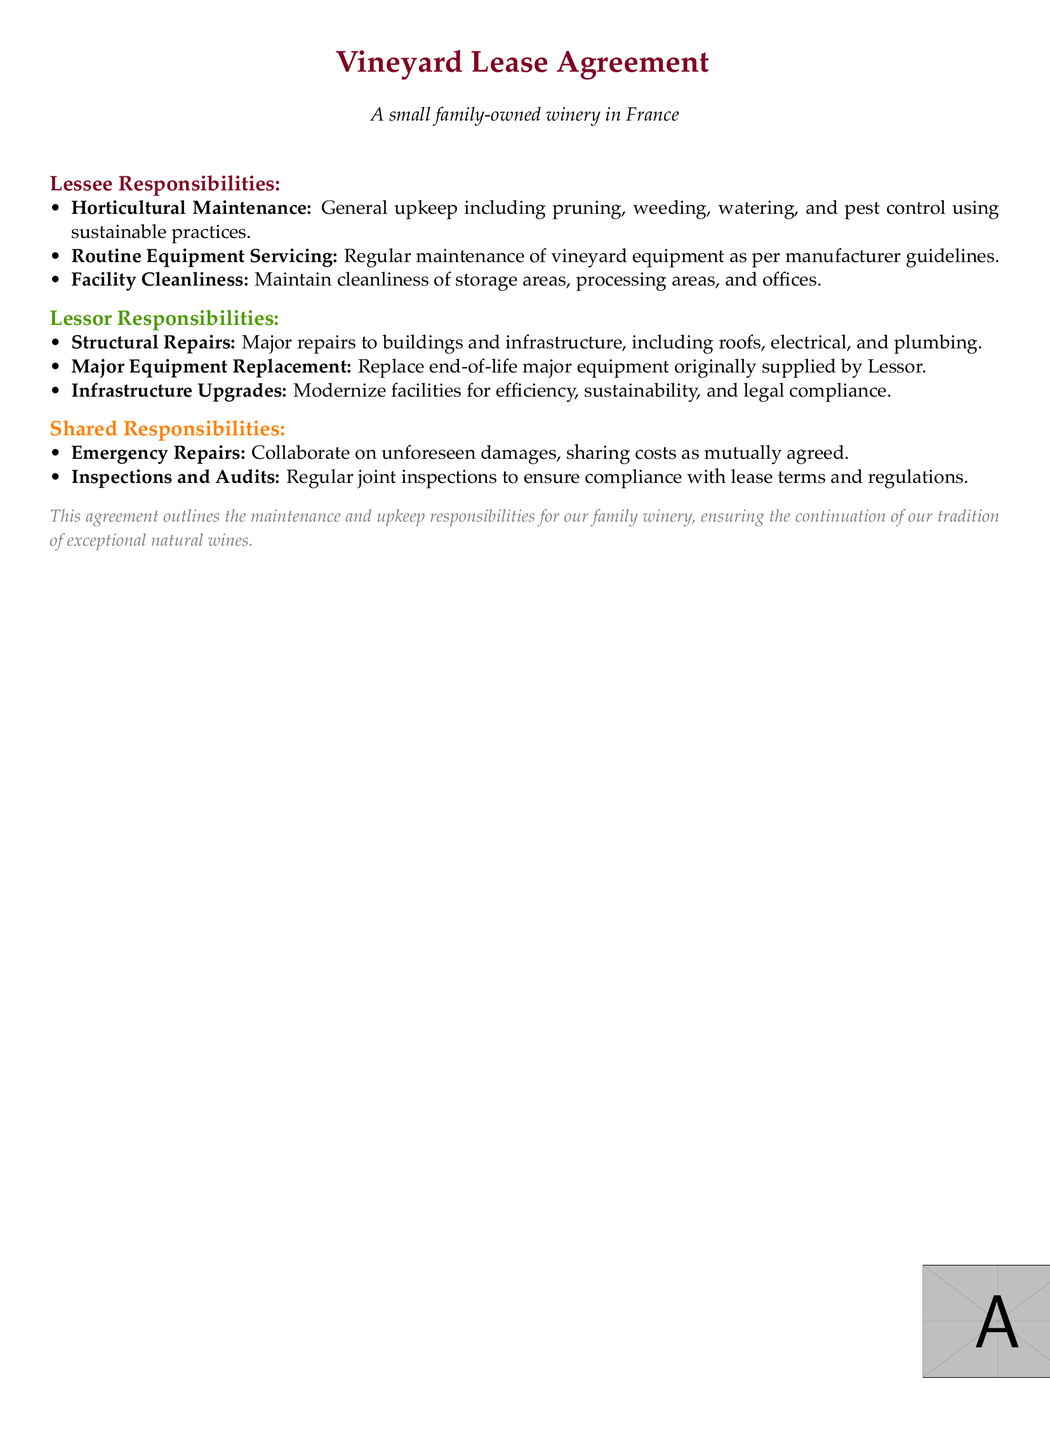What are the lessee's horticultural maintenance responsibilities? The lessee is responsible for general upkeep including pruning, weeding, watering, and pest control using sustainable practices.
Answer: General upkeep including pruning, weeding, watering, and pest control using sustainable practices What major repairs are the lessor responsible for? Major repairs to buildings and infrastructure include roofs, electrical, and plumbing.
Answer: Major repairs to buildings and infrastructure Who is responsible for routine equipment servicing? The responsibilities of routine equipment servicing fall on the lessee as per the document.
Answer: Lessee What type of upgrades is the lessor responsible for? The lessor is responsible for modernizing facilities for efficiency, sustainability, and legal compliance.
Answer: Infrastructure Upgrades What do both parties share the responsibility for? Emergency repairs and inspections and audits are shared responsibilities according to the document.
Answer: Emergency Repairs What is the primary purpose of this lease agreement? The lease agreement outlines maintenance and upkeep responsibilities for the family winery, ensuring the continuation of a tradition.
Answer: Continuation of our tradition of exceptional natural wines 